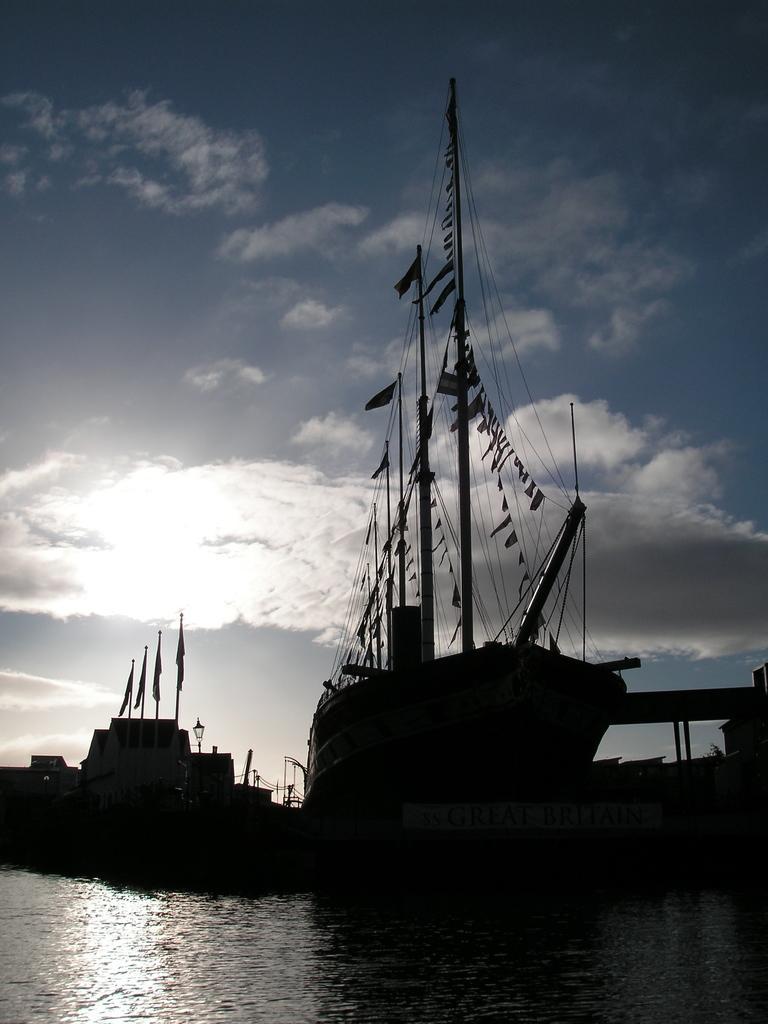Can you describe this image briefly? In the center of the image we can see the ships, poles, flags, light, ropes, bridge. At the bottom of the image we can see the water. At the top of the image we can see the clouds are present in the sky. 